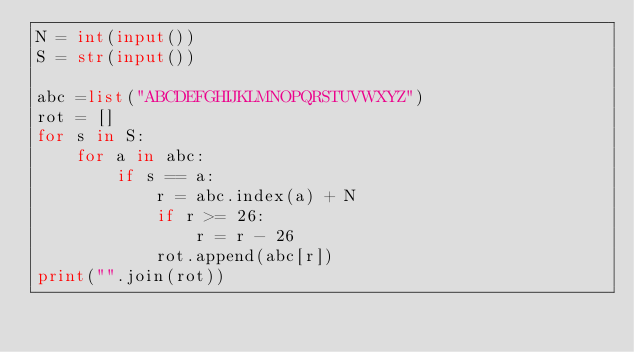Convert code to text. <code><loc_0><loc_0><loc_500><loc_500><_Python_>N = int(input())
S = str(input())

abc =list("ABCDEFGHIJKLMNOPQRSTUVWXYZ")
rot = []
for s in S:
    for a in abc:
        if s == a:
            r = abc.index(a) + N
            if r >= 26:
                r = r - 26 
            rot.append(abc[r])
print("".join(rot))</code> 